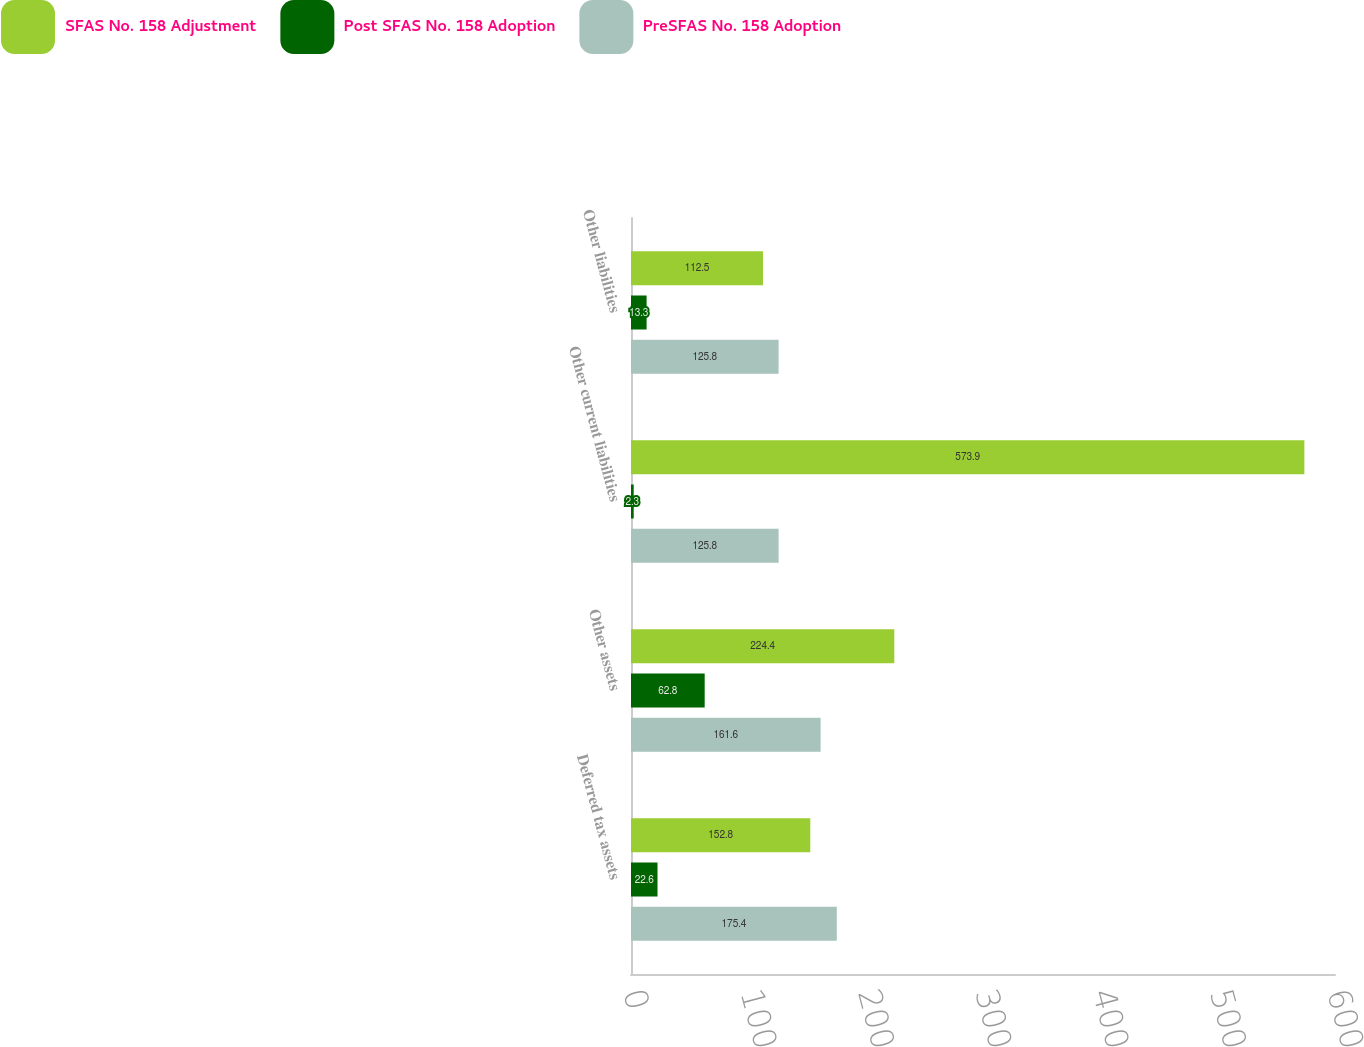Convert chart. <chart><loc_0><loc_0><loc_500><loc_500><stacked_bar_chart><ecel><fcel>Deferred tax assets<fcel>Other assets<fcel>Other current liabilities<fcel>Other liabilities<nl><fcel>SFAS No. 158 Adjustment<fcel>152.8<fcel>224.4<fcel>573.9<fcel>112.5<nl><fcel>Post SFAS No. 158 Adoption<fcel>22.6<fcel>62.8<fcel>2.3<fcel>13.3<nl><fcel>PreSFAS No. 158 Adoption<fcel>175.4<fcel>161.6<fcel>125.8<fcel>125.8<nl></chart> 